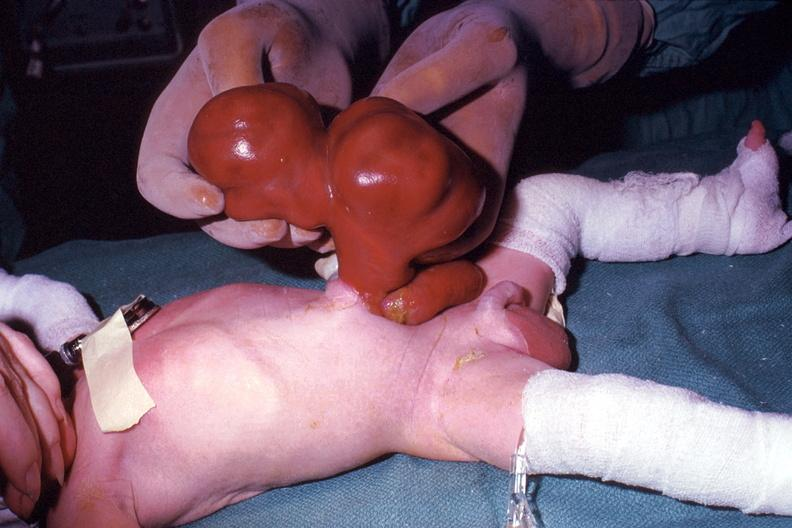does this image show a photo taken during life large lesion?
Answer the question using a single word or phrase. Yes 